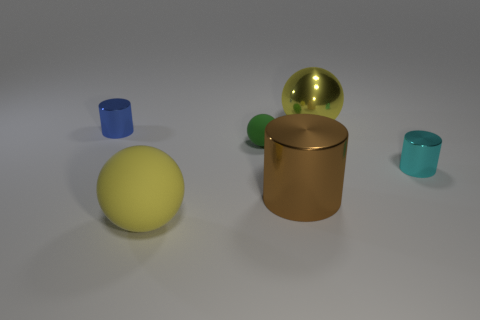Subtract all yellow spheres. How many were subtracted if there are1yellow spheres left? 1 Subtract all tiny cylinders. How many cylinders are left? 1 Add 1 small blue balls. How many objects exist? 7 Subtract all green balls. How many balls are left? 2 Add 4 small purple metallic things. How many small purple metallic things exist? 4 Subtract 0 green cylinders. How many objects are left? 6 Subtract 3 cylinders. How many cylinders are left? 0 Subtract all purple spheres. Subtract all red blocks. How many spheres are left? 3 Subtract all gray cylinders. How many yellow spheres are left? 2 Subtract all small yellow rubber cylinders. Subtract all brown shiny cylinders. How many objects are left? 5 